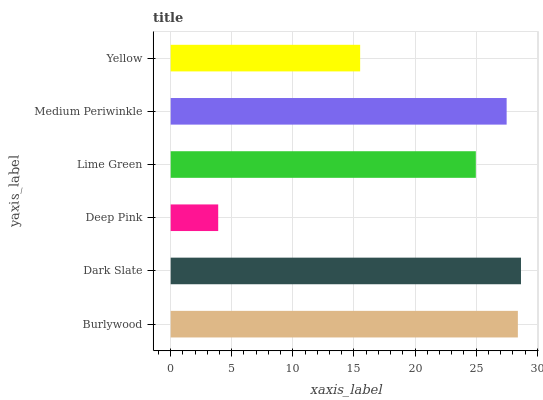Is Deep Pink the minimum?
Answer yes or no. Yes. Is Dark Slate the maximum?
Answer yes or no. Yes. Is Dark Slate the minimum?
Answer yes or no. No. Is Deep Pink the maximum?
Answer yes or no. No. Is Dark Slate greater than Deep Pink?
Answer yes or no. Yes. Is Deep Pink less than Dark Slate?
Answer yes or no. Yes. Is Deep Pink greater than Dark Slate?
Answer yes or no. No. Is Dark Slate less than Deep Pink?
Answer yes or no. No. Is Medium Periwinkle the high median?
Answer yes or no. Yes. Is Lime Green the low median?
Answer yes or no. Yes. Is Deep Pink the high median?
Answer yes or no. No. Is Dark Slate the low median?
Answer yes or no. No. 